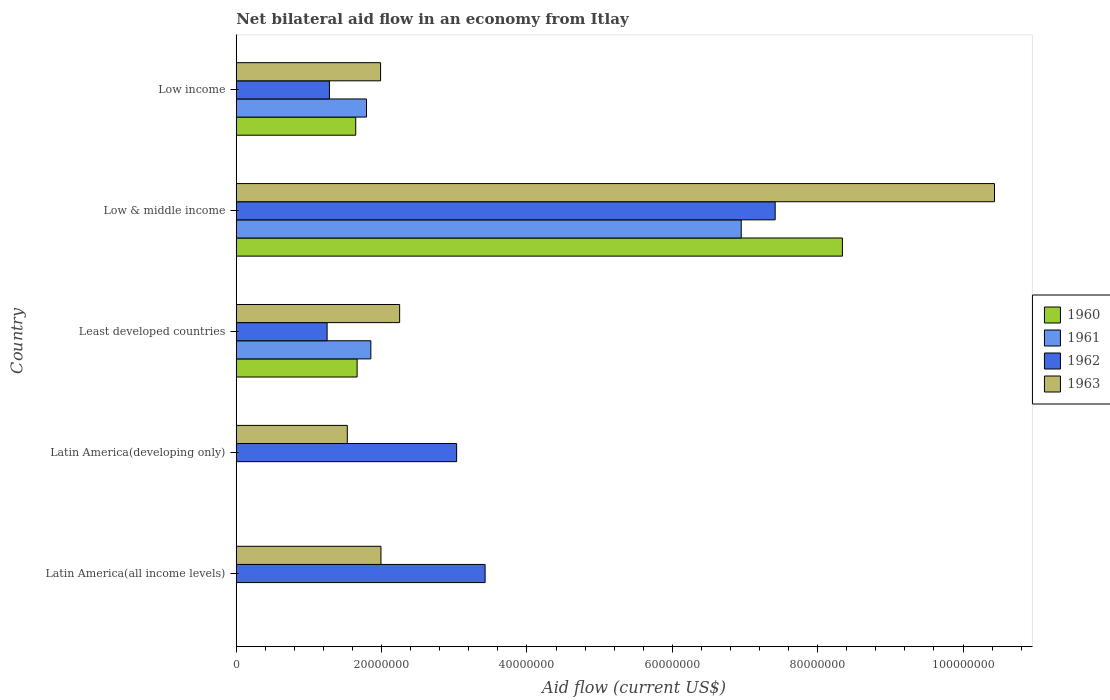How many groups of bars are there?
Offer a terse response. 5. Are the number of bars per tick equal to the number of legend labels?
Your answer should be very brief. No. How many bars are there on the 4th tick from the bottom?
Keep it short and to the point. 4. In how many cases, is the number of bars for a given country not equal to the number of legend labels?
Provide a succinct answer. 2. What is the net bilateral aid flow in 1963 in Low & middle income?
Make the answer very short. 1.04e+08. Across all countries, what is the maximum net bilateral aid flow in 1960?
Give a very brief answer. 8.34e+07. Across all countries, what is the minimum net bilateral aid flow in 1963?
Your answer should be very brief. 1.53e+07. What is the total net bilateral aid flow in 1963 in the graph?
Offer a very short reply. 1.82e+08. What is the difference between the net bilateral aid flow in 1962 in Latin America(all income levels) and that in Low income?
Offer a terse response. 2.14e+07. What is the difference between the net bilateral aid flow in 1960 in Latin America(developing only) and the net bilateral aid flow in 1963 in Low income?
Give a very brief answer. -1.99e+07. What is the average net bilateral aid flow in 1962 per country?
Offer a very short reply. 3.28e+07. What is the difference between the net bilateral aid flow in 1960 and net bilateral aid flow in 1961 in Low income?
Give a very brief answer. -1.48e+06. In how many countries, is the net bilateral aid flow in 1960 greater than 28000000 US$?
Your response must be concise. 1. What is the ratio of the net bilateral aid flow in 1961 in Least developed countries to that in Low & middle income?
Ensure brevity in your answer.  0.27. Is the net bilateral aid flow in 1962 in Latin America(developing only) less than that in Low & middle income?
Ensure brevity in your answer.  Yes. Is the difference between the net bilateral aid flow in 1960 in Low & middle income and Low income greater than the difference between the net bilateral aid flow in 1961 in Low & middle income and Low income?
Ensure brevity in your answer.  Yes. What is the difference between the highest and the second highest net bilateral aid flow in 1961?
Offer a very short reply. 5.10e+07. What is the difference between the highest and the lowest net bilateral aid flow in 1962?
Give a very brief answer. 6.16e+07. Is the sum of the net bilateral aid flow in 1961 in Least developed countries and Low & middle income greater than the maximum net bilateral aid flow in 1963 across all countries?
Your answer should be very brief. No. Is it the case that in every country, the sum of the net bilateral aid flow in 1961 and net bilateral aid flow in 1962 is greater than the sum of net bilateral aid flow in 1963 and net bilateral aid flow in 1960?
Your answer should be compact. No. Is it the case that in every country, the sum of the net bilateral aid flow in 1961 and net bilateral aid flow in 1962 is greater than the net bilateral aid flow in 1963?
Provide a short and direct response. Yes. How many bars are there?
Your response must be concise. 16. Are all the bars in the graph horizontal?
Keep it short and to the point. Yes. What is the difference between two consecutive major ticks on the X-axis?
Provide a succinct answer. 2.00e+07. Are the values on the major ticks of X-axis written in scientific E-notation?
Offer a terse response. No. Where does the legend appear in the graph?
Make the answer very short. Center right. What is the title of the graph?
Keep it short and to the point. Net bilateral aid flow in an economy from Itlay. What is the label or title of the Y-axis?
Your answer should be compact. Country. What is the Aid flow (current US$) of 1960 in Latin America(all income levels)?
Provide a succinct answer. 0. What is the Aid flow (current US$) in 1961 in Latin America(all income levels)?
Keep it short and to the point. 0. What is the Aid flow (current US$) of 1962 in Latin America(all income levels)?
Provide a succinct answer. 3.42e+07. What is the Aid flow (current US$) of 1963 in Latin America(all income levels)?
Your answer should be very brief. 1.99e+07. What is the Aid flow (current US$) of 1961 in Latin America(developing only)?
Your answer should be compact. 0. What is the Aid flow (current US$) of 1962 in Latin America(developing only)?
Give a very brief answer. 3.03e+07. What is the Aid flow (current US$) of 1963 in Latin America(developing only)?
Provide a short and direct response. 1.53e+07. What is the Aid flow (current US$) of 1960 in Least developed countries?
Make the answer very short. 1.66e+07. What is the Aid flow (current US$) in 1961 in Least developed countries?
Ensure brevity in your answer.  1.85e+07. What is the Aid flow (current US$) of 1962 in Least developed countries?
Give a very brief answer. 1.25e+07. What is the Aid flow (current US$) of 1963 in Least developed countries?
Your answer should be compact. 2.25e+07. What is the Aid flow (current US$) of 1960 in Low & middle income?
Your answer should be compact. 8.34e+07. What is the Aid flow (current US$) in 1961 in Low & middle income?
Make the answer very short. 6.95e+07. What is the Aid flow (current US$) in 1962 in Low & middle income?
Your response must be concise. 7.42e+07. What is the Aid flow (current US$) of 1963 in Low & middle income?
Provide a short and direct response. 1.04e+08. What is the Aid flow (current US$) in 1960 in Low income?
Ensure brevity in your answer.  1.64e+07. What is the Aid flow (current US$) in 1961 in Low income?
Ensure brevity in your answer.  1.79e+07. What is the Aid flow (current US$) in 1962 in Low income?
Provide a succinct answer. 1.28e+07. What is the Aid flow (current US$) of 1963 in Low income?
Give a very brief answer. 1.99e+07. Across all countries, what is the maximum Aid flow (current US$) of 1960?
Provide a short and direct response. 8.34e+07. Across all countries, what is the maximum Aid flow (current US$) of 1961?
Give a very brief answer. 6.95e+07. Across all countries, what is the maximum Aid flow (current US$) of 1962?
Ensure brevity in your answer.  7.42e+07. Across all countries, what is the maximum Aid flow (current US$) in 1963?
Make the answer very short. 1.04e+08. Across all countries, what is the minimum Aid flow (current US$) of 1961?
Keep it short and to the point. 0. Across all countries, what is the minimum Aid flow (current US$) of 1962?
Offer a terse response. 1.25e+07. Across all countries, what is the minimum Aid flow (current US$) of 1963?
Ensure brevity in your answer.  1.53e+07. What is the total Aid flow (current US$) in 1960 in the graph?
Make the answer very short. 1.16e+08. What is the total Aid flow (current US$) in 1961 in the graph?
Your answer should be very brief. 1.06e+08. What is the total Aid flow (current US$) in 1962 in the graph?
Your response must be concise. 1.64e+08. What is the total Aid flow (current US$) of 1963 in the graph?
Ensure brevity in your answer.  1.82e+08. What is the difference between the Aid flow (current US$) in 1962 in Latin America(all income levels) and that in Latin America(developing only)?
Offer a terse response. 3.92e+06. What is the difference between the Aid flow (current US$) in 1963 in Latin America(all income levels) and that in Latin America(developing only)?
Provide a succinct answer. 4.63e+06. What is the difference between the Aid flow (current US$) of 1962 in Latin America(all income levels) and that in Least developed countries?
Give a very brief answer. 2.17e+07. What is the difference between the Aid flow (current US$) in 1963 in Latin America(all income levels) and that in Least developed countries?
Offer a terse response. -2.57e+06. What is the difference between the Aid flow (current US$) in 1962 in Latin America(all income levels) and that in Low & middle income?
Give a very brief answer. -3.99e+07. What is the difference between the Aid flow (current US$) of 1963 in Latin America(all income levels) and that in Low & middle income?
Your answer should be very brief. -8.44e+07. What is the difference between the Aid flow (current US$) in 1962 in Latin America(all income levels) and that in Low income?
Keep it short and to the point. 2.14e+07. What is the difference between the Aid flow (current US$) of 1962 in Latin America(developing only) and that in Least developed countries?
Make the answer very short. 1.78e+07. What is the difference between the Aid flow (current US$) of 1963 in Latin America(developing only) and that in Least developed countries?
Your response must be concise. -7.20e+06. What is the difference between the Aid flow (current US$) in 1962 in Latin America(developing only) and that in Low & middle income?
Ensure brevity in your answer.  -4.38e+07. What is the difference between the Aid flow (current US$) of 1963 in Latin America(developing only) and that in Low & middle income?
Offer a terse response. -8.90e+07. What is the difference between the Aid flow (current US$) of 1962 in Latin America(developing only) and that in Low income?
Your answer should be compact. 1.75e+07. What is the difference between the Aid flow (current US$) of 1963 in Latin America(developing only) and that in Low income?
Provide a succinct answer. -4.58e+06. What is the difference between the Aid flow (current US$) in 1960 in Least developed countries and that in Low & middle income?
Ensure brevity in your answer.  -6.68e+07. What is the difference between the Aid flow (current US$) of 1961 in Least developed countries and that in Low & middle income?
Make the answer very short. -5.10e+07. What is the difference between the Aid flow (current US$) in 1962 in Least developed countries and that in Low & middle income?
Your answer should be very brief. -6.16e+07. What is the difference between the Aid flow (current US$) of 1963 in Least developed countries and that in Low & middle income?
Make the answer very short. -8.18e+07. What is the difference between the Aid flow (current US$) of 1960 in Least developed countries and that in Low income?
Provide a short and direct response. 1.90e+05. What is the difference between the Aid flow (current US$) of 1962 in Least developed countries and that in Low income?
Provide a succinct answer. -3.20e+05. What is the difference between the Aid flow (current US$) in 1963 in Least developed countries and that in Low income?
Provide a short and direct response. 2.62e+06. What is the difference between the Aid flow (current US$) in 1960 in Low & middle income and that in Low income?
Ensure brevity in your answer.  6.70e+07. What is the difference between the Aid flow (current US$) in 1961 in Low & middle income and that in Low income?
Offer a very short reply. 5.16e+07. What is the difference between the Aid flow (current US$) of 1962 in Low & middle income and that in Low income?
Your answer should be very brief. 6.13e+07. What is the difference between the Aid flow (current US$) in 1963 in Low & middle income and that in Low income?
Your answer should be compact. 8.45e+07. What is the difference between the Aid flow (current US$) of 1962 in Latin America(all income levels) and the Aid flow (current US$) of 1963 in Latin America(developing only)?
Offer a very short reply. 1.90e+07. What is the difference between the Aid flow (current US$) of 1962 in Latin America(all income levels) and the Aid flow (current US$) of 1963 in Least developed countries?
Offer a very short reply. 1.18e+07. What is the difference between the Aid flow (current US$) in 1962 in Latin America(all income levels) and the Aid flow (current US$) in 1963 in Low & middle income?
Keep it short and to the point. -7.01e+07. What is the difference between the Aid flow (current US$) in 1962 in Latin America(all income levels) and the Aid flow (current US$) in 1963 in Low income?
Offer a very short reply. 1.44e+07. What is the difference between the Aid flow (current US$) of 1962 in Latin America(developing only) and the Aid flow (current US$) of 1963 in Least developed countries?
Your answer should be compact. 7.84e+06. What is the difference between the Aid flow (current US$) in 1962 in Latin America(developing only) and the Aid flow (current US$) in 1963 in Low & middle income?
Your answer should be compact. -7.40e+07. What is the difference between the Aid flow (current US$) of 1962 in Latin America(developing only) and the Aid flow (current US$) of 1963 in Low income?
Make the answer very short. 1.05e+07. What is the difference between the Aid flow (current US$) in 1960 in Least developed countries and the Aid flow (current US$) in 1961 in Low & middle income?
Offer a very short reply. -5.28e+07. What is the difference between the Aid flow (current US$) of 1960 in Least developed countries and the Aid flow (current US$) of 1962 in Low & middle income?
Provide a short and direct response. -5.75e+07. What is the difference between the Aid flow (current US$) of 1960 in Least developed countries and the Aid flow (current US$) of 1963 in Low & middle income?
Provide a succinct answer. -8.77e+07. What is the difference between the Aid flow (current US$) in 1961 in Least developed countries and the Aid flow (current US$) in 1962 in Low & middle income?
Make the answer very short. -5.56e+07. What is the difference between the Aid flow (current US$) of 1961 in Least developed countries and the Aid flow (current US$) of 1963 in Low & middle income?
Offer a terse response. -8.58e+07. What is the difference between the Aid flow (current US$) in 1962 in Least developed countries and the Aid flow (current US$) in 1963 in Low & middle income?
Provide a short and direct response. -9.18e+07. What is the difference between the Aid flow (current US$) in 1960 in Least developed countries and the Aid flow (current US$) in 1961 in Low income?
Provide a short and direct response. -1.29e+06. What is the difference between the Aid flow (current US$) in 1960 in Least developed countries and the Aid flow (current US$) in 1962 in Low income?
Give a very brief answer. 3.81e+06. What is the difference between the Aid flow (current US$) in 1960 in Least developed countries and the Aid flow (current US$) in 1963 in Low income?
Provide a short and direct response. -3.23e+06. What is the difference between the Aid flow (current US$) of 1961 in Least developed countries and the Aid flow (current US$) of 1962 in Low income?
Provide a short and direct response. 5.70e+06. What is the difference between the Aid flow (current US$) of 1961 in Least developed countries and the Aid flow (current US$) of 1963 in Low income?
Your answer should be compact. -1.34e+06. What is the difference between the Aid flow (current US$) of 1962 in Least developed countries and the Aid flow (current US$) of 1963 in Low income?
Offer a terse response. -7.36e+06. What is the difference between the Aid flow (current US$) of 1960 in Low & middle income and the Aid flow (current US$) of 1961 in Low income?
Provide a succinct answer. 6.55e+07. What is the difference between the Aid flow (current US$) of 1960 in Low & middle income and the Aid flow (current US$) of 1962 in Low income?
Your response must be concise. 7.06e+07. What is the difference between the Aid flow (current US$) of 1960 in Low & middle income and the Aid flow (current US$) of 1963 in Low income?
Ensure brevity in your answer.  6.35e+07. What is the difference between the Aid flow (current US$) of 1961 in Low & middle income and the Aid flow (current US$) of 1962 in Low income?
Provide a succinct answer. 5.67e+07. What is the difference between the Aid flow (current US$) in 1961 in Low & middle income and the Aid flow (current US$) in 1963 in Low income?
Your answer should be compact. 4.96e+07. What is the difference between the Aid flow (current US$) in 1962 in Low & middle income and the Aid flow (current US$) in 1963 in Low income?
Your answer should be very brief. 5.43e+07. What is the average Aid flow (current US$) in 1960 per country?
Offer a very short reply. 2.33e+07. What is the average Aid flow (current US$) of 1961 per country?
Your answer should be compact. 2.12e+07. What is the average Aid flow (current US$) of 1962 per country?
Provide a short and direct response. 3.28e+07. What is the average Aid flow (current US$) of 1963 per country?
Your answer should be very brief. 3.64e+07. What is the difference between the Aid flow (current US$) of 1962 and Aid flow (current US$) of 1963 in Latin America(all income levels)?
Keep it short and to the point. 1.43e+07. What is the difference between the Aid flow (current US$) in 1962 and Aid flow (current US$) in 1963 in Latin America(developing only)?
Offer a very short reply. 1.50e+07. What is the difference between the Aid flow (current US$) of 1960 and Aid flow (current US$) of 1961 in Least developed countries?
Your answer should be very brief. -1.89e+06. What is the difference between the Aid flow (current US$) of 1960 and Aid flow (current US$) of 1962 in Least developed countries?
Offer a very short reply. 4.13e+06. What is the difference between the Aid flow (current US$) in 1960 and Aid flow (current US$) in 1963 in Least developed countries?
Ensure brevity in your answer.  -5.85e+06. What is the difference between the Aid flow (current US$) in 1961 and Aid flow (current US$) in 1962 in Least developed countries?
Offer a very short reply. 6.02e+06. What is the difference between the Aid flow (current US$) of 1961 and Aid flow (current US$) of 1963 in Least developed countries?
Keep it short and to the point. -3.96e+06. What is the difference between the Aid flow (current US$) of 1962 and Aid flow (current US$) of 1963 in Least developed countries?
Your answer should be compact. -9.98e+06. What is the difference between the Aid flow (current US$) of 1960 and Aid flow (current US$) of 1961 in Low & middle income?
Your answer should be compact. 1.39e+07. What is the difference between the Aid flow (current US$) of 1960 and Aid flow (current US$) of 1962 in Low & middle income?
Ensure brevity in your answer.  9.25e+06. What is the difference between the Aid flow (current US$) of 1960 and Aid flow (current US$) of 1963 in Low & middle income?
Your answer should be compact. -2.09e+07. What is the difference between the Aid flow (current US$) in 1961 and Aid flow (current US$) in 1962 in Low & middle income?
Keep it short and to the point. -4.67e+06. What is the difference between the Aid flow (current US$) of 1961 and Aid flow (current US$) of 1963 in Low & middle income?
Give a very brief answer. -3.48e+07. What is the difference between the Aid flow (current US$) in 1962 and Aid flow (current US$) in 1963 in Low & middle income?
Your answer should be very brief. -3.02e+07. What is the difference between the Aid flow (current US$) of 1960 and Aid flow (current US$) of 1961 in Low income?
Provide a short and direct response. -1.48e+06. What is the difference between the Aid flow (current US$) of 1960 and Aid flow (current US$) of 1962 in Low income?
Your answer should be compact. 3.62e+06. What is the difference between the Aid flow (current US$) in 1960 and Aid flow (current US$) in 1963 in Low income?
Provide a short and direct response. -3.42e+06. What is the difference between the Aid flow (current US$) of 1961 and Aid flow (current US$) of 1962 in Low income?
Make the answer very short. 5.10e+06. What is the difference between the Aid flow (current US$) of 1961 and Aid flow (current US$) of 1963 in Low income?
Ensure brevity in your answer.  -1.94e+06. What is the difference between the Aid flow (current US$) in 1962 and Aid flow (current US$) in 1963 in Low income?
Make the answer very short. -7.04e+06. What is the ratio of the Aid flow (current US$) in 1962 in Latin America(all income levels) to that in Latin America(developing only)?
Your answer should be very brief. 1.13. What is the ratio of the Aid flow (current US$) of 1963 in Latin America(all income levels) to that in Latin America(developing only)?
Your answer should be compact. 1.3. What is the ratio of the Aid flow (current US$) of 1962 in Latin America(all income levels) to that in Least developed countries?
Provide a succinct answer. 2.74. What is the ratio of the Aid flow (current US$) in 1963 in Latin America(all income levels) to that in Least developed countries?
Offer a very short reply. 0.89. What is the ratio of the Aid flow (current US$) of 1962 in Latin America(all income levels) to that in Low & middle income?
Keep it short and to the point. 0.46. What is the ratio of the Aid flow (current US$) of 1963 in Latin America(all income levels) to that in Low & middle income?
Offer a terse response. 0.19. What is the ratio of the Aid flow (current US$) in 1962 in Latin America(all income levels) to that in Low income?
Ensure brevity in your answer.  2.67. What is the ratio of the Aid flow (current US$) in 1963 in Latin America(all income levels) to that in Low income?
Your response must be concise. 1. What is the ratio of the Aid flow (current US$) of 1962 in Latin America(developing only) to that in Least developed countries?
Offer a terse response. 2.43. What is the ratio of the Aid flow (current US$) in 1963 in Latin America(developing only) to that in Least developed countries?
Keep it short and to the point. 0.68. What is the ratio of the Aid flow (current US$) in 1962 in Latin America(developing only) to that in Low & middle income?
Keep it short and to the point. 0.41. What is the ratio of the Aid flow (current US$) of 1963 in Latin America(developing only) to that in Low & middle income?
Give a very brief answer. 0.15. What is the ratio of the Aid flow (current US$) in 1962 in Latin America(developing only) to that in Low income?
Keep it short and to the point. 2.37. What is the ratio of the Aid flow (current US$) of 1963 in Latin America(developing only) to that in Low income?
Offer a very short reply. 0.77. What is the ratio of the Aid flow (current US$) in 1960 in Least developed countries to that in Low & middle income?
Provide a succinct answer. 0.2. What is the ratio of the Aid flow (current US$) in 1961 in Least developed countries to that in Low & middle income?
Your answer should be very brief. 0.27. What is the ratio of the Aid flow (current US$) in 1962 in Least developed countries to that in Low & middle income?
Your answer should be very brief. 0.17. What is the ratio of the Aid flow (current US$) in 1963 in Least developed countries to that in Low & middle income?
Your answer should be compact. 0.22. What is the ratio of the Aid flow (current US$) of 1960 in Least developed countries to that in Low income?
Your response must be concise. 1.01. What is the ratio of the Aid flow (current US$) of 1961 in Least developed countries to that in Low income?
Offer a very short reply. 1.03. What is the ratio of the Aid flow (current US$) in 1963 in Least developed countries to that in Low income?
Ensure brevity in your answer.  1.13. What is the ratio of the Aid flow (current US$) in 1960 in Low & middle income to that in Low income?
Make the answer very short. 5.07. What is the ratio of the Aid flow (current US$) of 1961 in Low & middle income to that in Low income?
Offer a terse response. 3.88. What is the ratio of the Aid flow (current US$) of 1962 in Low & middle income to that in Low income?
Provide a succinct answer. 5.78. What is the ratio of the Aid flow (current US$) in 1963 in Low & middle income to that in Low income?
Offer a very short reply. 5.25. What is the difference between the highest and the second highest Aid flow (current US$) in 1960?
Give a very brief answer. 6.68e+07. What is the difference between the highest and the second highest Aid flow (current US$) in 1961?
Offer a terse response. 5.10e+07. What is the difference between the highest and the second highest Aid flow (current US$) of 1962?
Offer a very short reply. 3.99e+07. What is the difference between the highest and the second highest Aid flow (current US$) of 1963?
Your answer should be very brief. 8.18e+07. What is the difference between the highest and the lowest Aid flow (current US$) in 1960?
Your answer should be compact. 8.34e+07. What is the difference between the highest and the lowest Aid flow (current US$) in 1961?
Offer a very short reply. 6.95e+07. What is the difference between the highest and the lowest Aid flow (current US$) in 1962?
Offer a very short reply. 6.16e+07. What is the difference between the highest and the lowest Aid flow (current US$) in 1963?
Your answer should be very brief. 8.90e+07. 